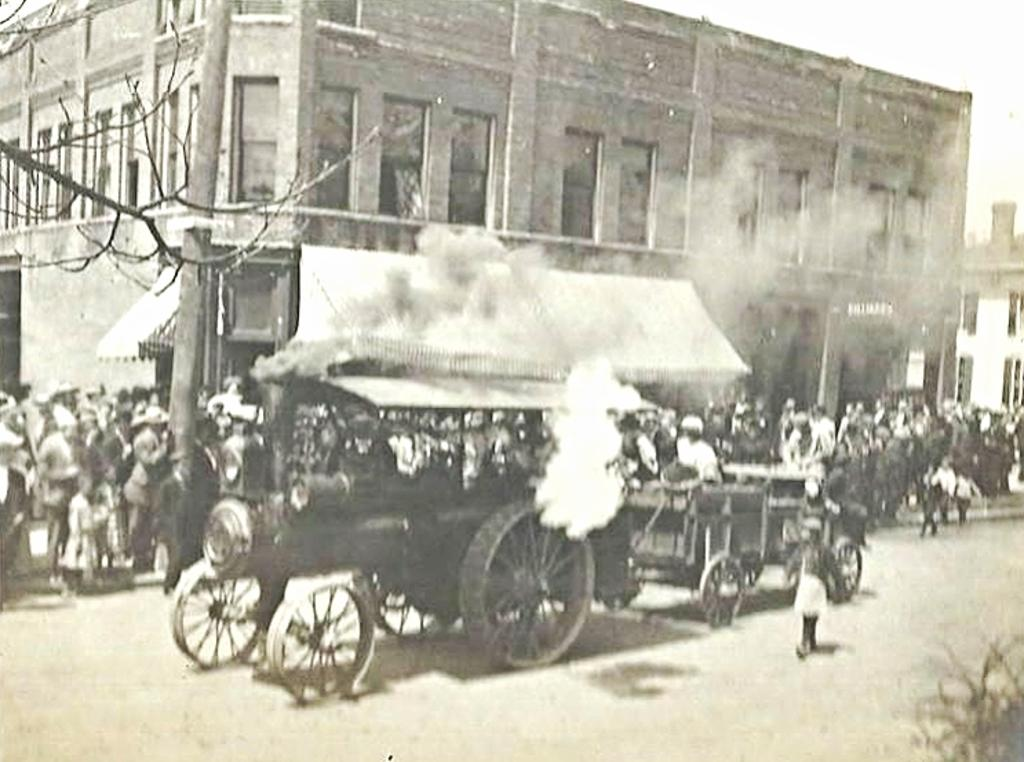What type of structures can be seen in the image? There are buildings in the image. What feature of the buildings can be observed? There are windows visible in the image. What natural element is present in the image? There is a tree in the image. What are the people in the image doing? There are people standing on the pavement in the image. What type of transportation is visible in the image? There are vehicles on the road in the image. What object can be seen standing upright in the image? There is a pole in the image. What type of soup is being served in the image? There is no soup present in the image. What tax-related information can be found on the receipt in the image? There is no receipt present in the image. 